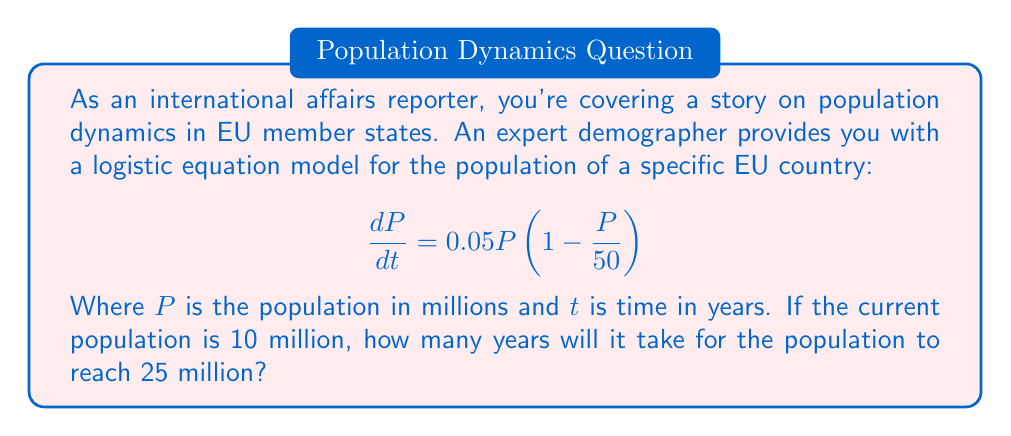Give your solution to this math problem. To solve this problem, we need to use the logistic equation and its solution. The general form of the logistic equation is:

$$\frac{dP}{dt} = rP\left(1 - \frac{P}{K}\right)$$

Where $r$ is the growth rate and $K$ is the carrying capacity. In our case, $r = 0.05$ and $K = 50$ million.

The solution to the logistic equation is:

$$P(t) = \frac{K}{1 + \left(\frac{K}{P_0} - 1\right)e^{-rt}}$$

Where $P_0$ is the initial population.

Let's solve this step by step:

1) We know $P_0 = 10$ million, $K = 50$ million, and $r = 0.05$.

2) We want to find $t$ when $P(t) = 25$ million.

3) Substituting these values into the equation:

   $$25 = \frac{50}{1 + \left(\frac{50}{10} - 1\right)e^{-0.05t}}$$

4) Simplify:

   $$25 = \frac{50}{1 + 4e^{-0.05t}}$$

5) Multiply both sides by $(1 + 4e^{-0.05t})$:

   $$25(1 + 4e^{-0.05t}) = 50$$

6) Expand:

   $$25 + 100e^{-0.05t} = 50$$

7) Subtract 25 from both sides:

   $$100e^{-0.05t} = 25$$

8) Divide both sides by 100:

   $$e^{-0.05t} = 0.25$$

9) Take the natural log of both sides:

   $$-0.05t = \ln(0.25)$$

10) Solve for $t$:

    $$t = -\frac{\ln(0.25)}{0.05} \approx 27.73$$

Therefore, it will take approximately 27.73 years for the population to reach 25 million.
Answer: It will take approximately 27.73 years for the population to reach 25 million. 